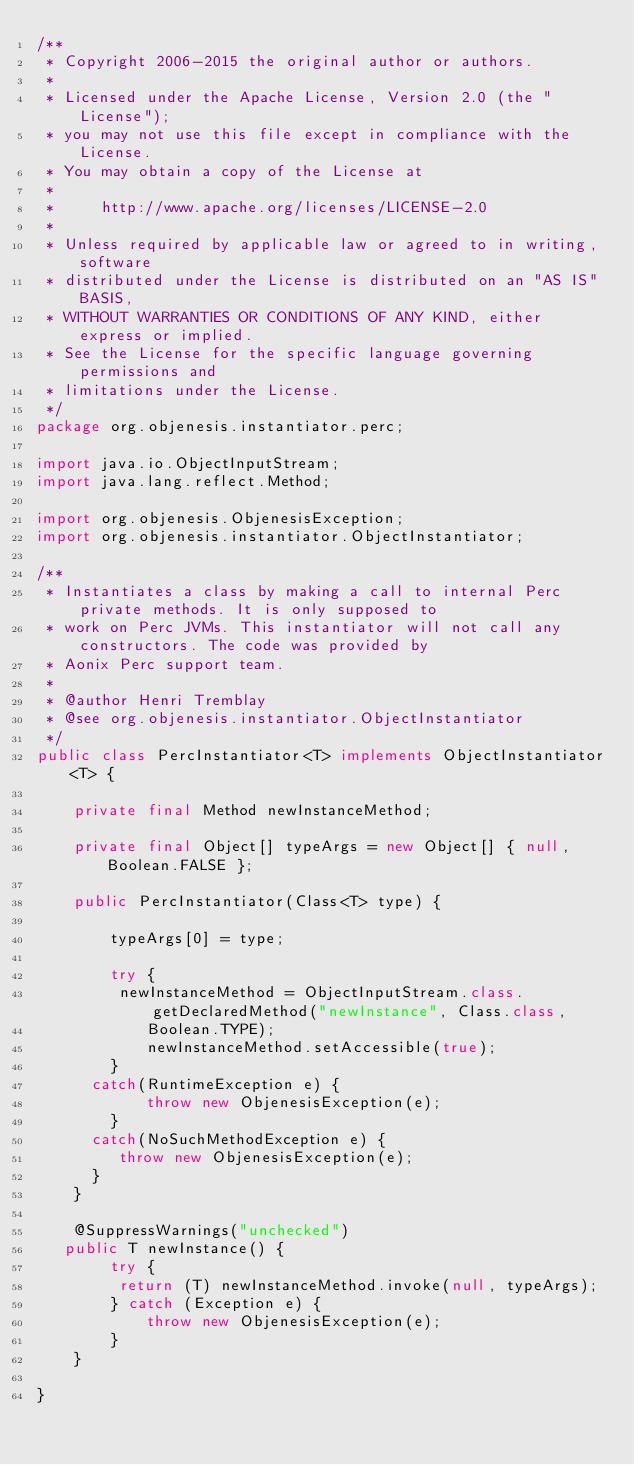<code> <loc_0><loc_0><loc_500><loc_500><_Java_>/**
 * Copyright 2006-2015 the original author or authors.
 *
 * Licensed under the Apache License, Version 2.0 (the "License");
 * you may not use this file except in compliance with the License.
 * You may obtain a copy of the License at
 *
 *     http://www.apache.org/licenses/LICENSE-2.0
 *
 * Unless required by applicable law or agreed to in writing, software
 * distributed under the License is distributed on an "AS IS" BASIS,
 * WITHOUT WARRANTIES OR CONDITIONS OF ANY KIND, either express or implied.
 * See the License for the specific language governing permissions and
 * limitations under the License.
 */
package org.objenesis.instantiator.perc;

import java.io.ObjectInputStream;
import java.lang.reflect.Method;

import org.objenesis.ObjenesisException;
import org.objenesis.instantiator.ObjectInstantiator;

/**
 * Instantiates a class by making a call to internal Perc private methods. It is only supposed to
 * work on Perc JVMs. This instantiator will not call any constructors. The code was provided by
 * Aonix Perc support team.
 * 
 * @author Henri Tremblay
 * @see org.objenesis.instantiator.ObjectInstantiator
 */
public class PercInstantiator<T> implements ObjectInstantiator<T> {

	private final Method newInstanceMethod;

	private final Object[] typeArgs = new Object[] { null, Boolean.FALSE };

	public PercInstantiator(Class<T> type) {

		typeArgs[0] = type;

		try {
         newInstanceMethod = ObjectInputStream.class.getDeclaredMethod("newInstance", Class.class,
            Boolean.TYPE);
			newInstanceMethod.setAccessible(true);
		}
      catch(RuntimeException e) {
			throw new ObjenesisException(e);
		}
      catch(NoSuchMethodException e) {
         throw new ObjenesisException(e);
      }
	}

	@SuppressWarnings("unchecked")
   public T newInstance() {
		try {
         return (T) newInstanceMethod.invoke(null, typeArgs);
		} catch (Exception e) {
			throw new ObjenesisException(e);
		}
	}

}
</code> 